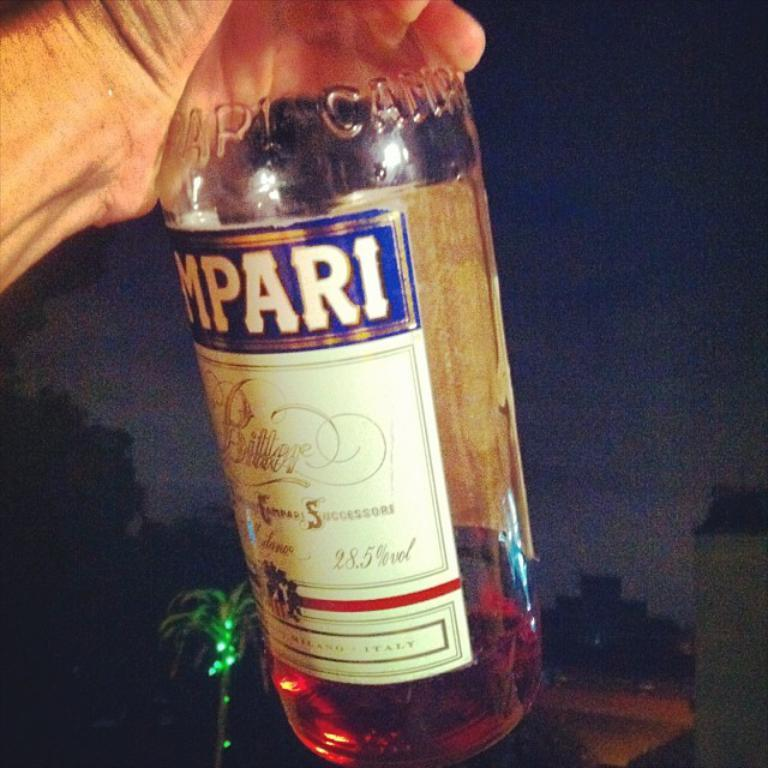Provide a one-sentence caption for the provided image. A person is holding a Campari Bitters bottle. 